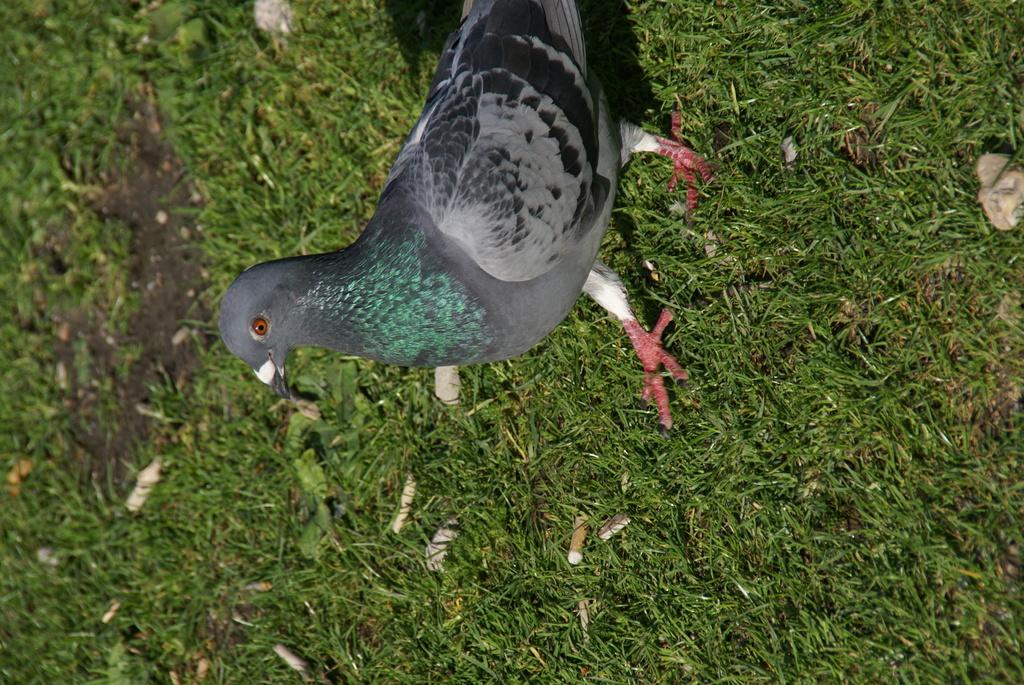What type of bird is in the image? There is a pigeon in the image. Where is the pigeon located? The pigeon is on the ground. What color is the pigeon? The pigeon is grey in color. What type of vegetation is visible in the image? There is grass visible in the image. What arithmetic problem is the pigeon solving in the image? There is no arithmetic problem present in the image, as it features a pigeon on the ground. Where is the shelf located in the image? There is no shelf present in the image. 